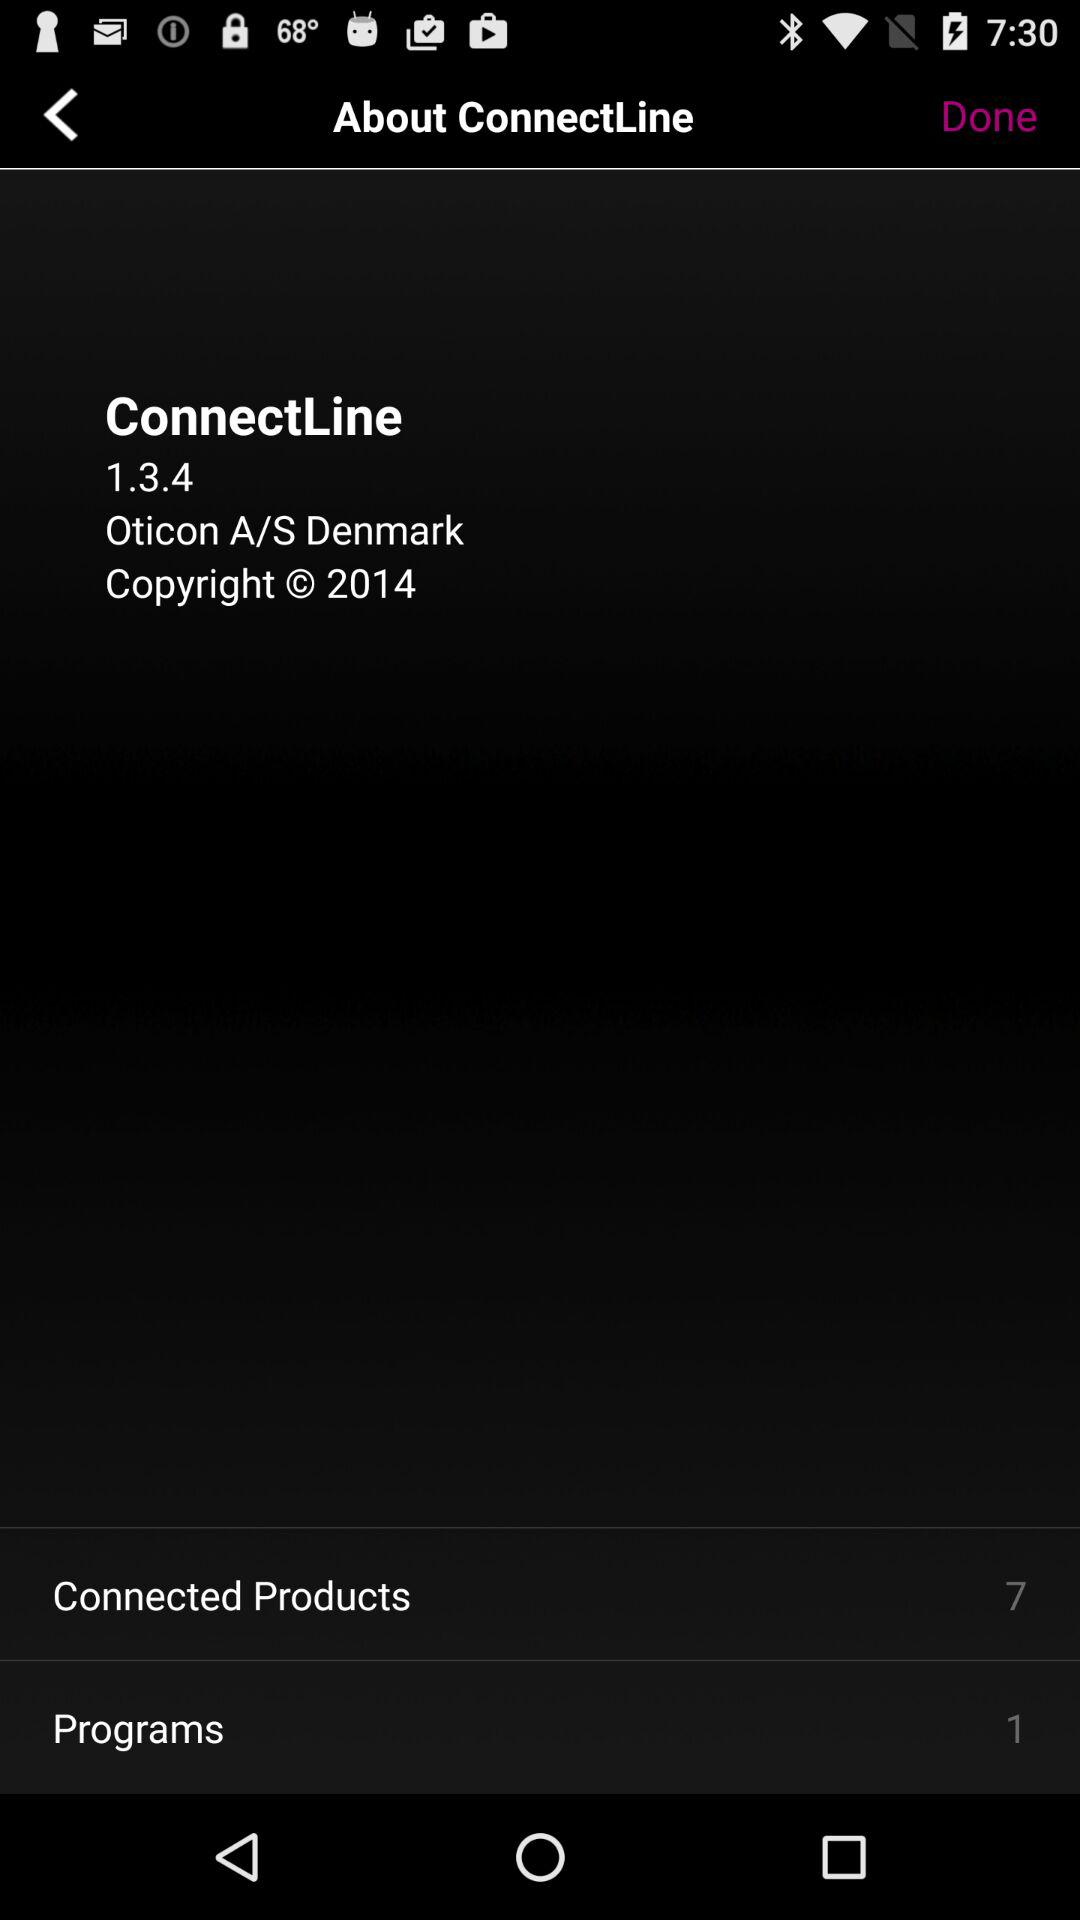How many "Connected Products" are shown here? There are 7 "Connected Products". 